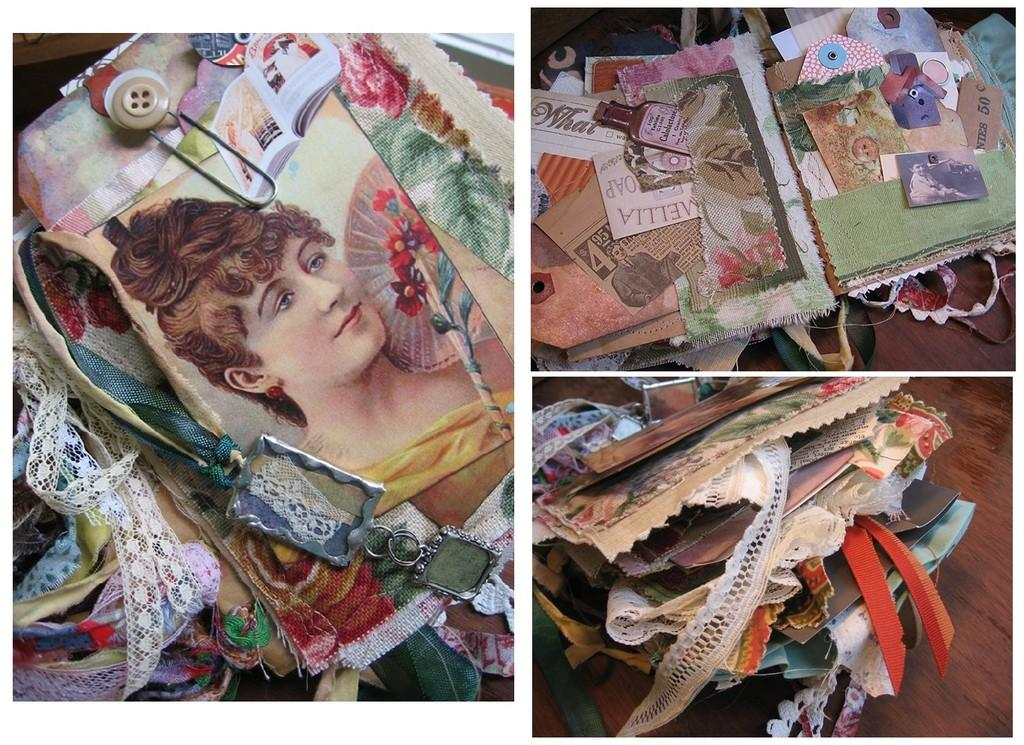What type of artwork is depicted in the image? The image is a collage. What are some of the elements that make up the collage? There are ribbons, cards, photos, and various objects in the collage. Can you describe the ribbons in the collage? The ribbons in the collage are colorful and add a decorative touch to the artwork. What other types of items can be found in the collage? Besides ribbons, there are cards and photos, as well as various objects. Can you see a tent in the collage? There is no tent present in the collage. How many ants are crawling on the cards in the collage? There are no ants present in the collage. 